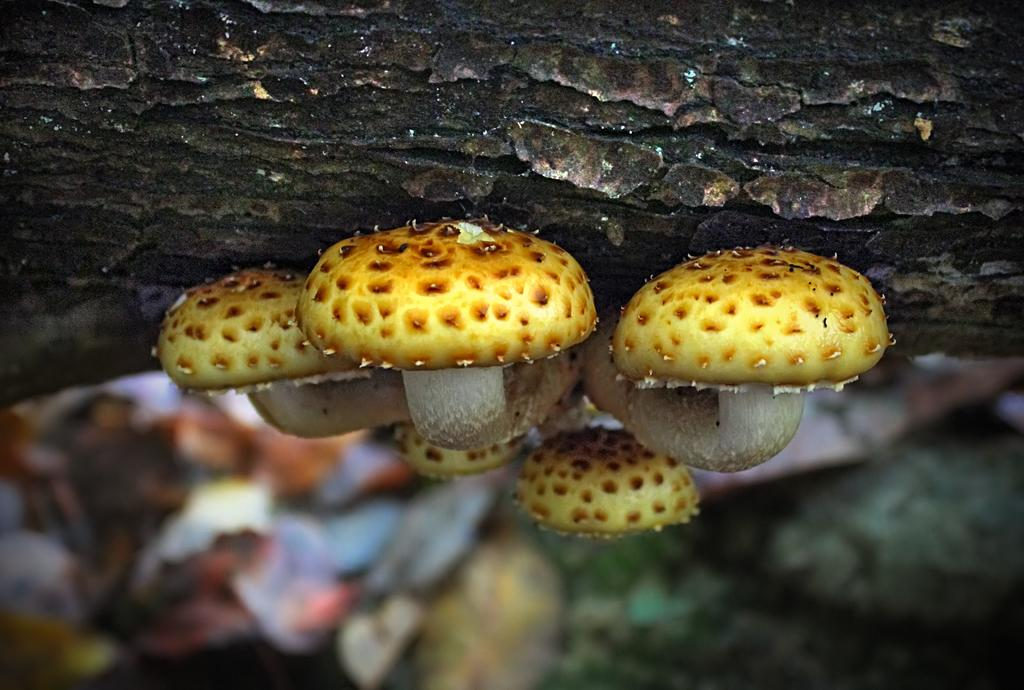What type of fungi can be seen in the image? There are mushrooms in the image. Can you describe the background of the image? The background of the image is blurred. What appliance is being used to transport the mushrooms in the image? There is no appliance or transportation depicted in the image; it only shows mushrooms and a blurred background. 